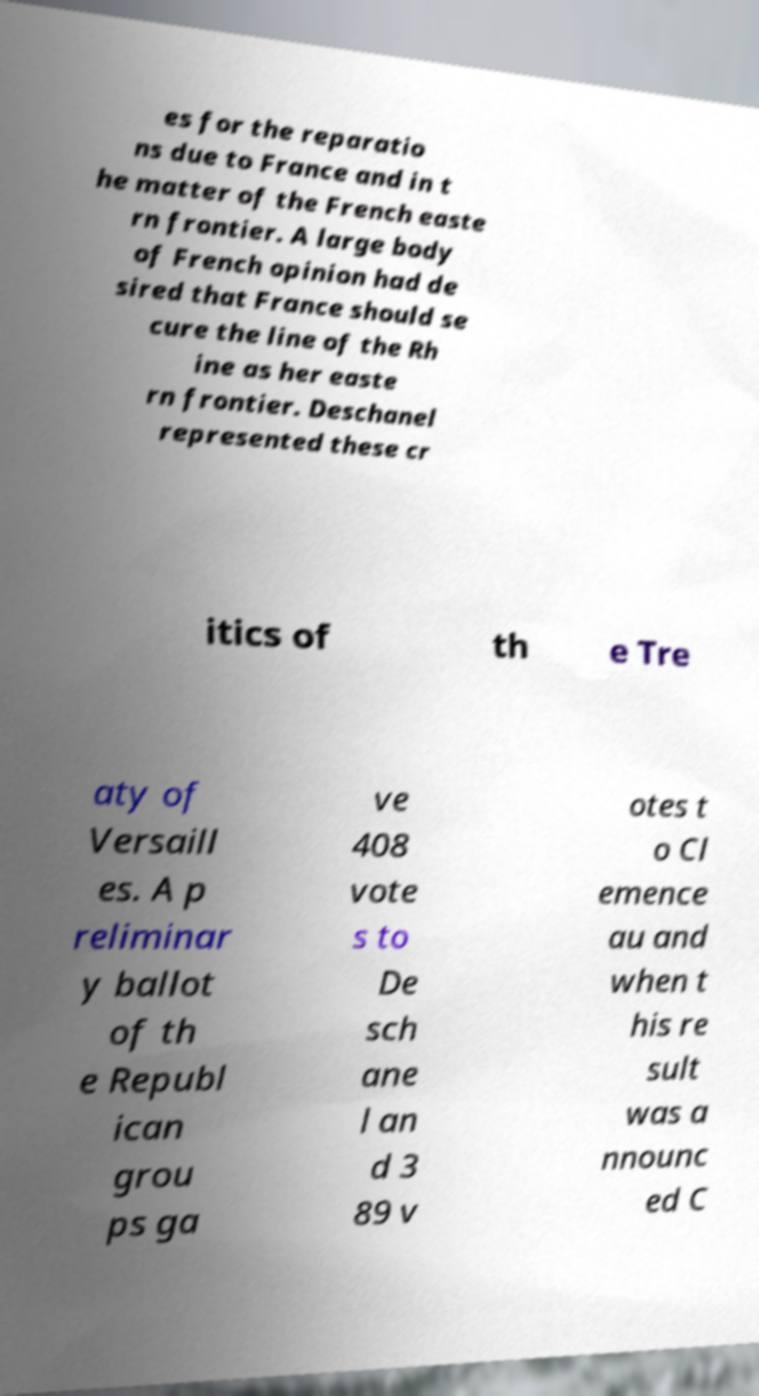Could you assist in decoding the text presented in this image and type it out clearly? es for the reparatio ns due to France and in t he matter of the French easte rn frontier. A large body of French opinion had de sired that France should se cure the line of the Rh ine as her easte rn frontier. Deschanel represented these cr itics of th e Tre aty of Versaill es. A p reliminar y ballot of th e Republ ican grou ps ga ve 408 vote s to De sch ane l an d 3 89 v otes t o Cl emence au and when t his re sult was a nnounc ed C 